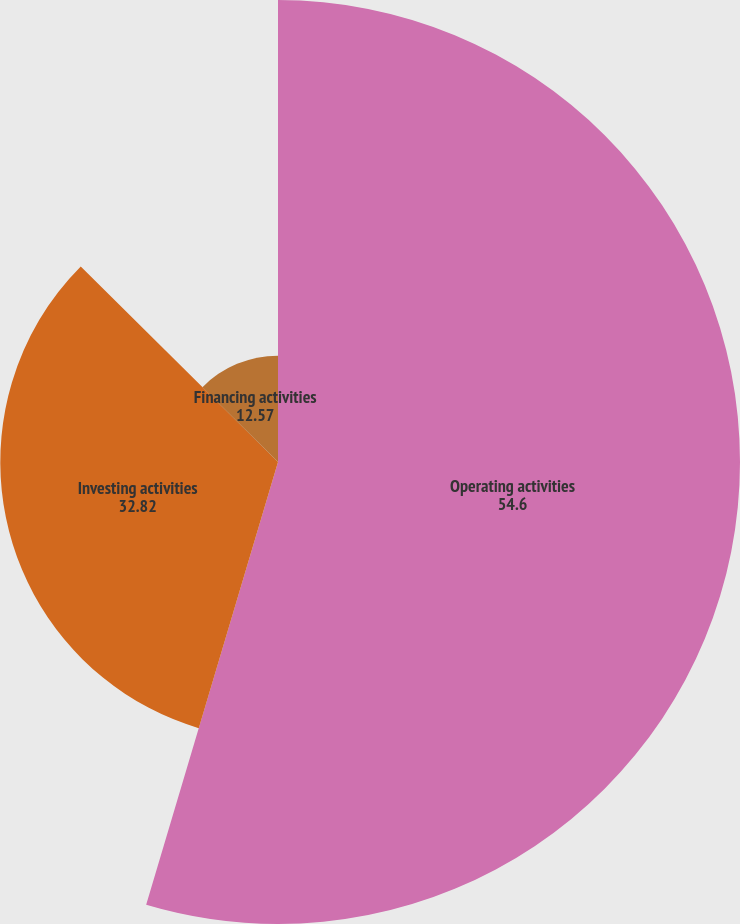Convert chart. <chart><loc_0><loc_0><loc_500><loc_500><pie_chart><fcel>Operating activities<fcel>Investing activities<fcel>Financing activities<nl><fcel>54.6%<fcel>32.82%<fcel>12.57%<nl></chart> 